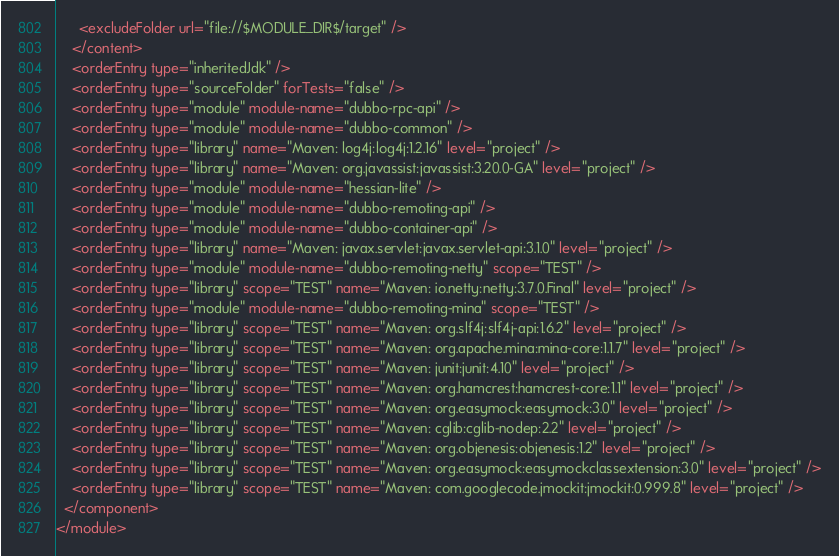Convert code to text. <code><loc_0><loc_0><loc_500><loc_500><_XML_>      <excludeFolder url="file://$MODULE_DIR$/target" />
    </content>
    <orderEntry type="inheritedJdk" />
    <orderEntry type="sourceFolder" forTests="false" />
    <orderEntry type="module" module-name="dubbo-rpc-api" />
    <orderEntry type="module" module-name="dubbo-common" />
    <orderEntry type="library" name="Maven: log4j:log4j:1.2.16" level="project" />
    <orderEntry type="library" name="Maven: org.javassist:javassist:3.20.0-GA" level="project" />
    <orderEntry type="module" module-name="hessian-lite" />
    <orderEntry type="module" module-name="dubbo-remoting-api" />
    <orderEntry type="module" module-name="dubbo-container-api" />
    <orderEntry type="library" name="Maven: javax.servlet:javax.servlet-api:3.1.0" level="project" />
    <orderEntry type="module" module-name="dubbo-remoting-netty" scope="TEST" />
    <orderEntry type="library" scope="TEST" name="Maven: io.netty:netty:3.7.0.Final" level="project" />
    <orderEntry type="module" module-name="dubbo-remoting-mina" scope="TEST" />
    <orderEntry type="library" scope="TEST" name="Maven: org.slf4j:slf4j-api:1.6.2" level="project" />
    <orderEntry type="library" scope="TEST" name="Maven: org.apache.mina:mina-core:1.1.7" level="project" />
    <orderEntry type="library" scope="TEST" name="Maven: junit:junit:4.10" level="project" />
    <orderEntry type="library" scope="TEST" name="Maven: org.hamcrest:hamcrest-core:1.1" level="project" />
    <orderEntry type="library" scope="TEST" name="Maven: org.easymock:easymock:3.0" level="project" />
    <orderEntry type="library" scope="TEST" name="Maven: cglib:cglib-nodep:2.2" level="project" />
    <orderEntry type="library" scope="TEST" name="Maven: org.objenesis:objenesis:1.2" level="project" />
    <orderEntry type="library" scope="TEST" name="Maven: org.easymock:easymockclassextension:3.0" level="project" />
    <orderEntry type="library" scope="TEST" name="Maven: com.googlecode.jmockit:jmockit:0.999.8" level="project" />
  </component>
</module></code> 